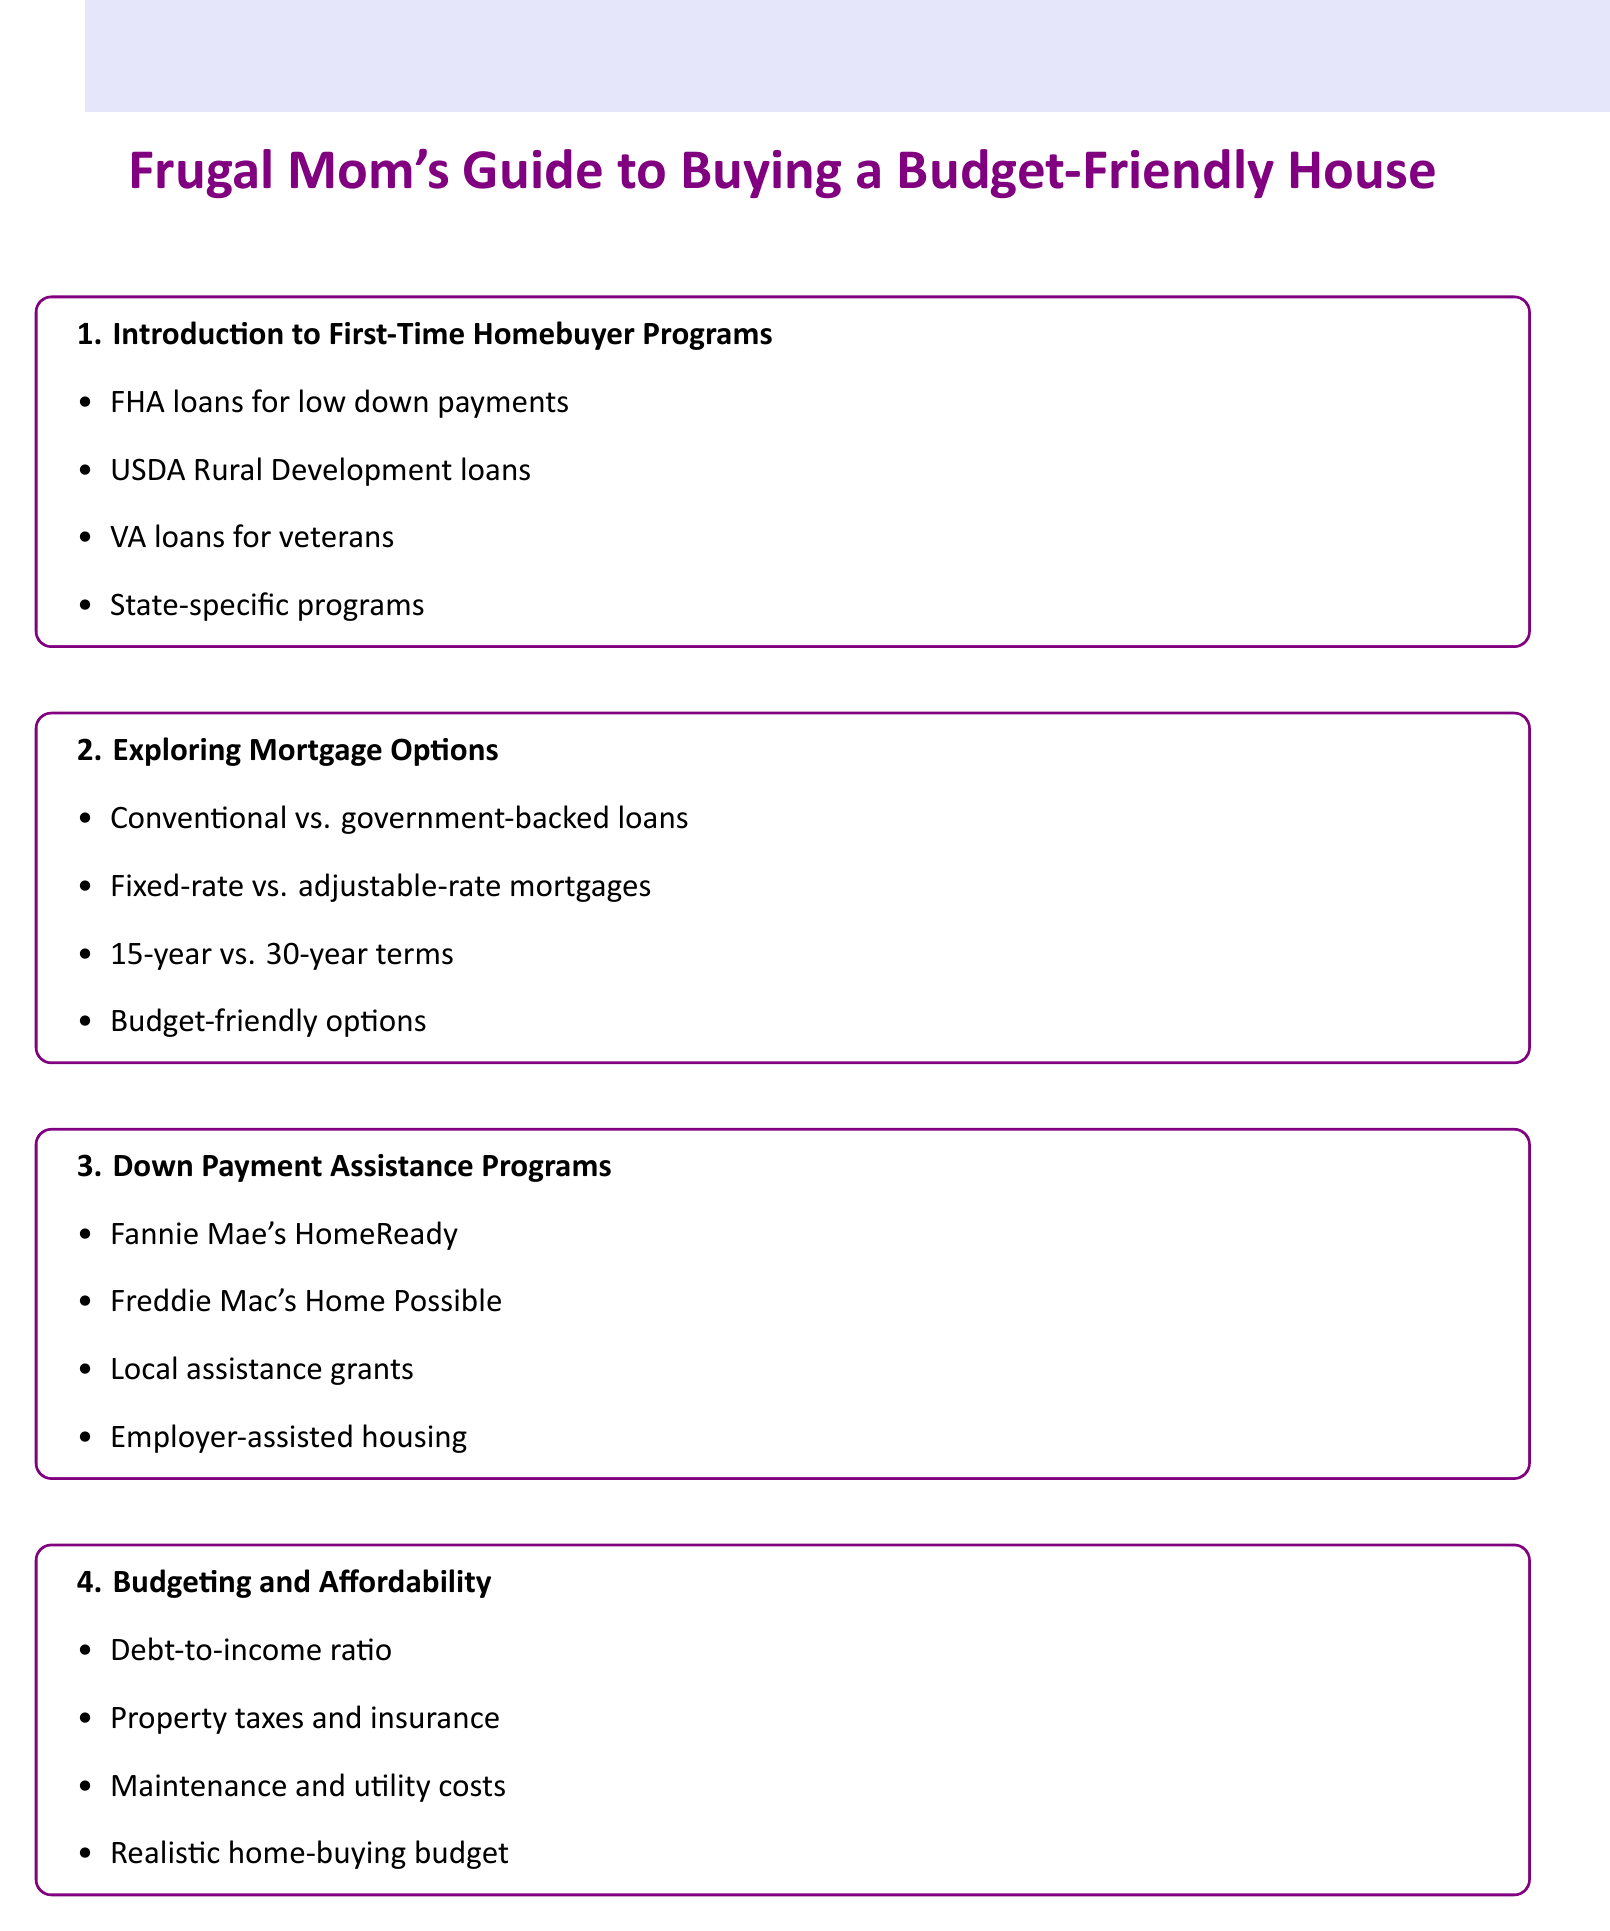What is the first item in the agenda? The first item in the agenda is about introducing first-time homebuyer programs.
Answer: Introduction to First-Time Homebuyer Programs What type of loan is specifically for veterans? The document mentions a specific loan type tailored for veterans and active-duty military.
Answer: VA loans Which program helps with low down payments? The agenda includes a program intended for those needing low down payments.
Answer: FHA loans for low down payments What is one method to improve credit scores mentioned? The document lists several strategies for improving credit scores, one of which is mentioned here.
Answer: Tips for boosting credit score quickly How many types of mortgage options are discussed? The agenda lists various mortgage options, suggesting how many are covered.
Answer: 4 What is an example of a down payment assistance program? The document provides examples of programs aiding with down payments, such as one that starts with "F".
Answer: Fannie Mae's HomeReady program What financial aspect is calculated in budgeting? This part of the agenda focuses on a specific financial calculation related to budgeting.
Answer: Calculating debt-to-income ratio What is a reason for creating an emergency fund after purchase? The agenda advises on post-purchase planning, mentioning a specific reason for an emergency fund.
Answer: For home repairs 